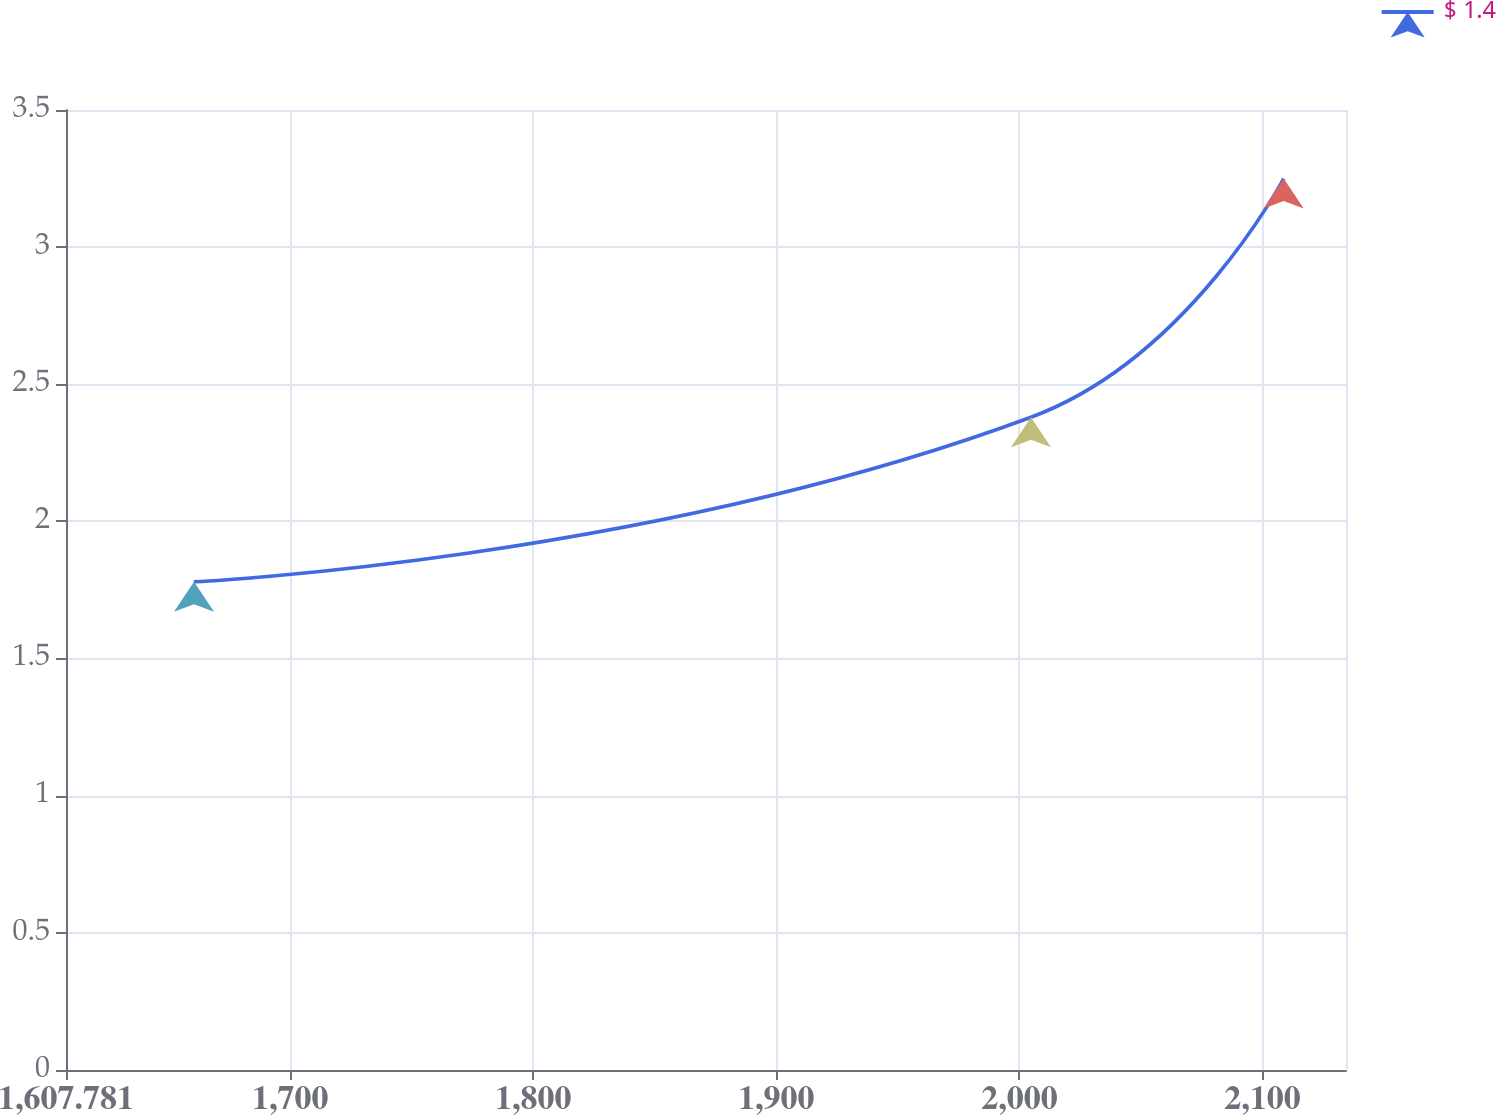Convert chart. <chart><loc_0><loc_0><loc_500><loc_500><line_chart><ecel><fcel>$ 1.4<nl><fcel>1660.44<fcel>1.78<nl><fcel>2004.77<fcel>2.38<nl><fcel>2108.74<fcel>3.25<nl><fcel>2187.03<fcel>3.4<nl></chart> 